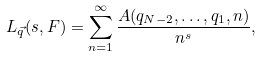<formula> <loc_0><loc_0><loc_500><loc_500>L _ { \vec { q } } ( s , F ) = \sum _ { n = 1 } ^ { \infty } \frac { A ( q _ { N - 2 } , \dots , q _ { 1 } , n ) } { n ^ { s } } ,</formula> 